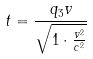<formula> <loc_0><loc_0><loc_500><loc_500>t = \frac { q _ { 3 } v } { \sqrt { 1 \cdot \frac { v ^ { 2 } } { c ^ { 2 } } } }</formula> 